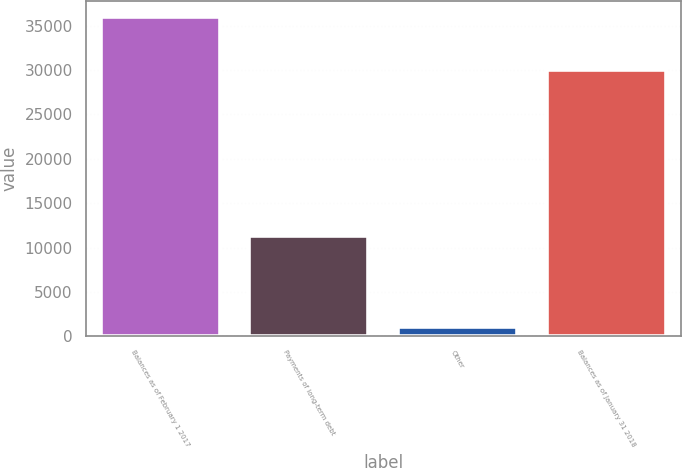<chart> <loc_0><loc_0><loc_500><loc_500><bar_chart><fcel>Balances as of February 1 2017<fcel>Payments of long-term debt<fcel>Other<fcel>Balances as of January 31 2018<nl><fcel>36015<fcel>11272<fcel>1050<fcel>30045<nl></chart> 